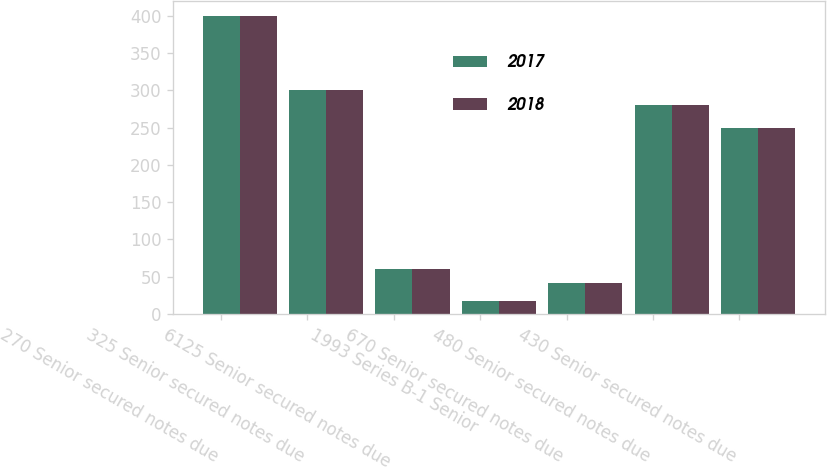Convert chart. <chart><loc_0><loc_0><loc_500><loc_500><stacked_bar_chart><ecel><fcel>270 Senior secured notes due<fcel>325 Senior secured notes due<fcel>6125 Senior secured notes due<fcel>1993 Series B-1 Senior<fcel>670 Senior secured notes due<fcel>480 Senior secured notes due<fcel>430 Senior secured notes due<nl><fcel>2017<fcel>400<fcel>300<fcel>60<fcel>17<fcel>42<fcel>280<fcel>250<nl><fcel>2018<fcel>400<fcel>300<fcel>60<fcel>17<fcel>42<fcel>280<fcel>250<nl></chart> 